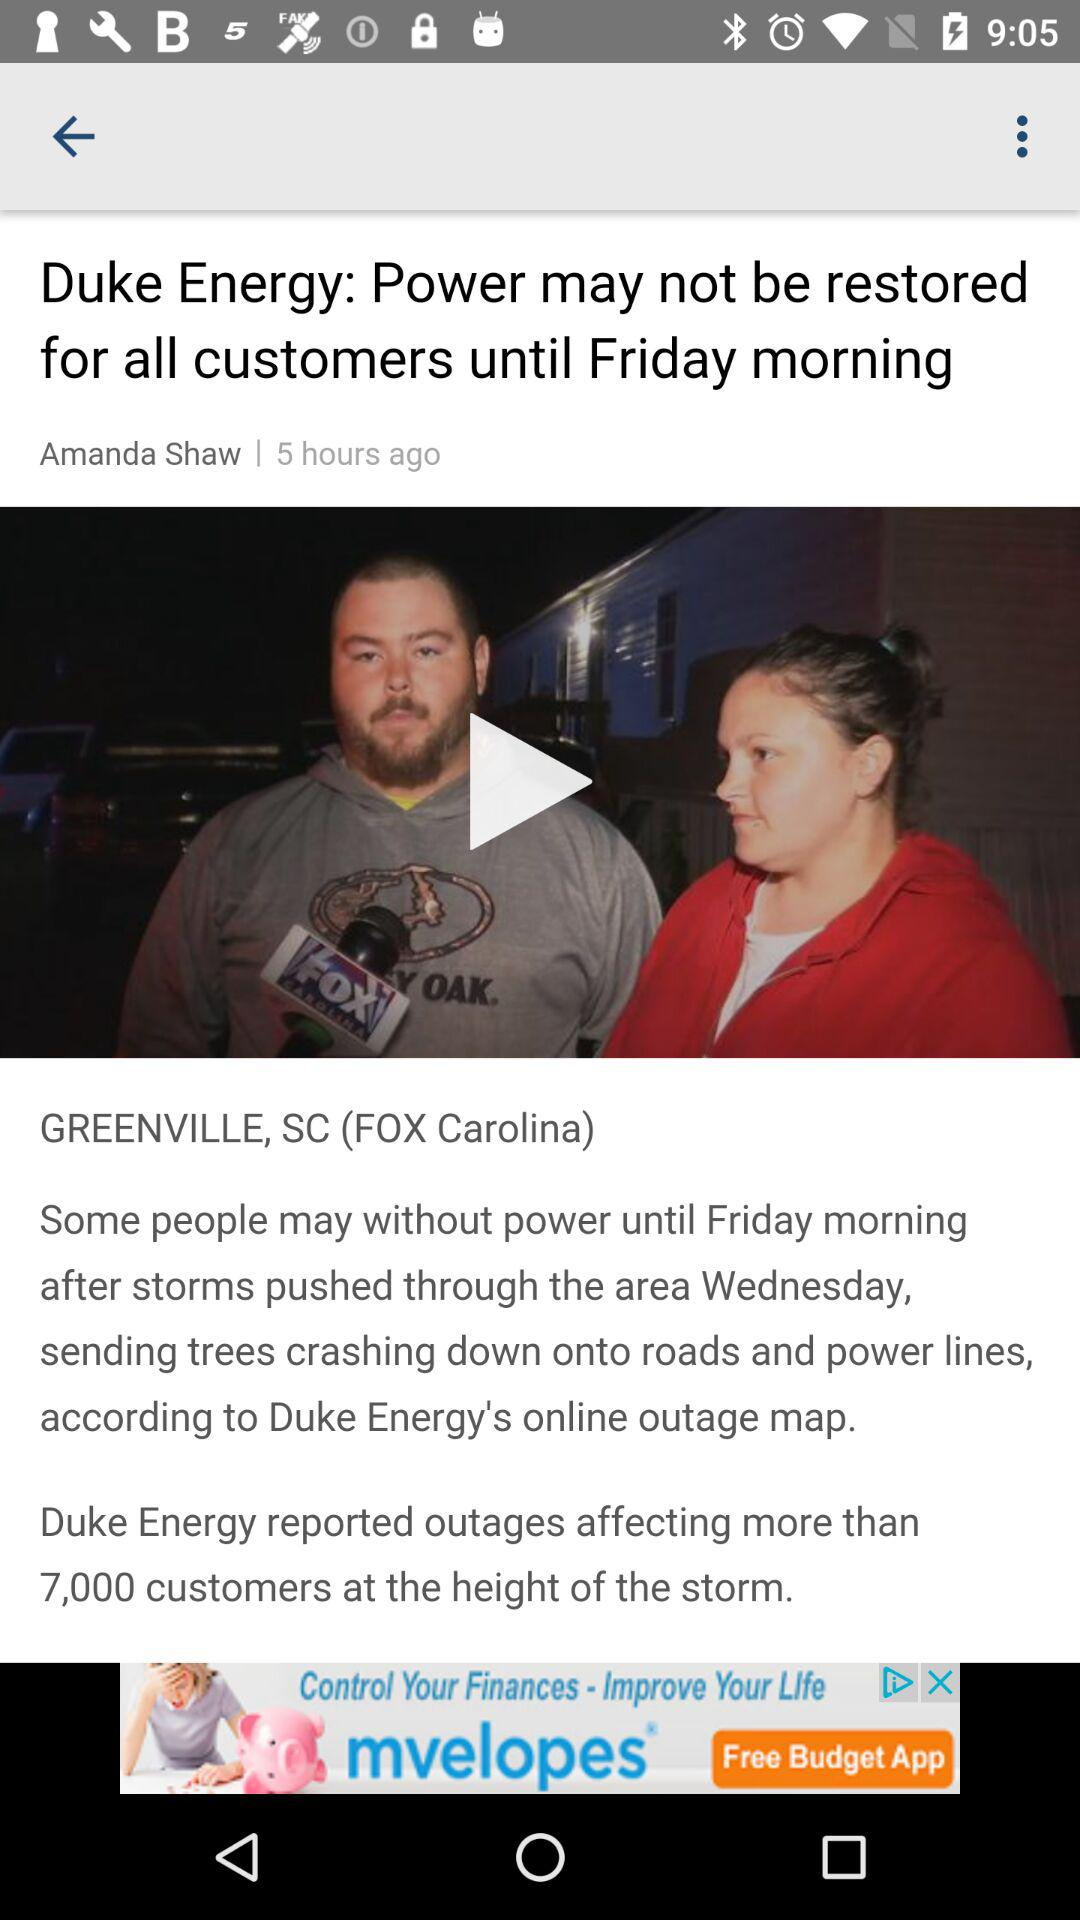Who is the author of the article? The author is Amanda Shaw. 